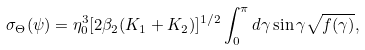Convert formula to latex. <formula><loc_0><loc_0><loc_500><loc_500>\sigma _ { \Theta } ( \psi ) = \eta ^ { 3 } _ { 0 } [ 2 \beta _ { 2 } ( K _ { 1 } + K _ { 2 } ) ] ^ { 1 / 2 } \int ^ { \pi } _ { 0 } d \gamma \sin \gamma \sqrt { f ( \gamma ) } ,</formula> 